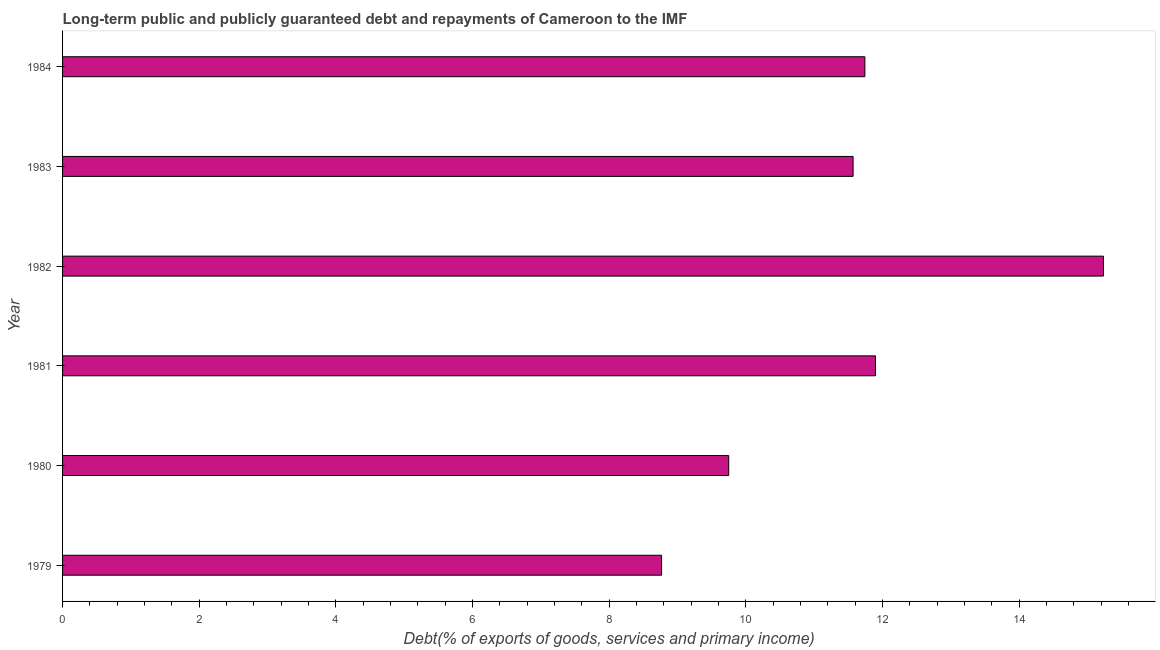Does the graph contain grids?
Your response must be concise. No. What is the title of the graph?
Make the answer very short. Long-term public and publicly guaranteed debt and repayments of Cameroon to the IMF. What is the label or title of the X-axis?
Make the answer very short. Debt(% of exports of goods, services and primary income). What is the label or title of the Y-axis?
Your answer should be very brief. Year. What is the debt service in 1981?
Ensure brevity in your answer.  11.9. Across all years, what is the maximum debt service?
Your answer should be very brief. 15.23. Across all years, what is the minimum debt service?
Provide a short and direct response. 8.77. In which year was the debt service minimum?
Offer a terse response. 1979. What is the sum of the debt service?
Make the answer very short. 68.95. What is the difference between the debt service in 1983 and 1984?
Offer a terse response. -0.17. What is the average debt service per year?
Offer a terse response. 11.49. What is the median debt service?
Keep it short and to the point. 11.65. In how many years, is the debt service greater than 4 %?
Provide a short and direct response. 6. What is the ratio of the debt service in 1980 to that in 1983?
Provide a succinct answer. 0.84. Is the difference between the debt service in 1979 and 1983 greater than the difference between any two years?
Make the answer very short. No. What is the difference between the highest and the second highest debt service?
Your response must be concise. 3.34. Is the sum of the debt service in 1980 and 1984 greater than the maximum debt service across all years?
Make the answer very short. Yes. What is the difference between the highest and the lowest debt service?
Offer a very short reply. 6.47. Are all the bars in the graph horizontal?
Your response must be concise. Yes. How many years are there in the graph?
Offer a very short reply. 6. Are the values on the major ticks of X-axis written in scientific E-notation?
Provide a succinct answer. No. What is the Debt(% of exports of goods, services and primary income) in 1979?
Offer a terse response. 8.77. What is the Debt(% of exports of goods, services and primary income) in 1980?
Your response must be concise. 9.75. What is the Debt(% of exports of goods, services and primary income) in 1981?
Provide a short and direct response. 11.9. What is the Debt(% of exports of goods, services and primary income) of 1982?
Keep it short and to the point. 15.23. What is the Debt(% of exports of goods, services and primary income) in 1983?
Make the answer very short. 11.57. What is the Debt(% of exports of goods, services and primary income) in 1984?
Offer a terse response. 11.74. What is the difference between the Debt(% of exports of goods, services and primary income) in 1979 and 1980?
Your answer should be very brief. -0.98. What is the difference between the Debt(% of exports of goods, services and primary income) in 1979 and 1981?
Offer a very short reply. -3.13. What is the difference between the Debt(% of exports of goods, services and primary income) in 1979 and 1982?
Keep it short and to the point. -6.47. What is the difference between the Debt(% of exports of goods, services and primary income) in 1979 and 1983?
Ensure brevity in your answer.  -2.8. What is the difference between the Debt(% of exports of goods, services and primary income) in 1979 and 1984?
Make the answer very short. -2.97. What is the difference between the Debt(% of exports of goods, services and primary income) in 1980 and 1981?
Your answer should be compact. -2.15. What is the difference between the Debt(% of exports of goods, services and primary income) in 1980 and 1982?
Offer a very short reply. -5.48. What is the difference between the Debt(% of exports of goods, services and primary income) in 1980 and 1983?
Give a very brief answer. -1.82. What is the difference between the Debt(% of exports of goods, services and primary income) in 1980 and 1984?
Provide a short and direct response. -1.99. What is the difference between the Debt(% of exports of goods, services and primary income) in 1981 and 1982?
Provide a succinct answer. -3.34. What is the difference between the Debt(% of exports of goods, services and primary income) in 1981 and 1983?
Offer a very short reply. 0.33. What is the difference between the Debt(% of exports of goods, services and primary income) in 1981 and 1984?
Your answer should be compact. 0.16. What is the difference between the Debt(% of exports of goods, services and primary income) in 1982 and 1983?
Offer a very short reply. 3.66. What is the difference between the Debt(% of exports of goods, services and primary income) in 1982 and 1984?
Ensure brevity in your answer.  3.49. What is the difference between the Debt(% of exports of goods, services and primary income) in 1983 and 1984?
Provide a short and direct response. -0.17. What is the ratio of the Debt(% of exports of goods, services and primary income) in 1979 to that in 1980?
Give a very brief answer. 0.9. What is the ratio of the Debt(% of exports of goods, services and primary income) in 1979 to that in 1981?
Give a very brief answer. 0.74. What is the ratio of the Debt(% of exports of goods, services and primary income) in 1979 to that in 1982?
Offer a very short reply. 0.57. What is the ratio of the Debt(% of exports of goods, services and primary income) in 1979 to that in 1983?
Your answer should be compact. 0.76. What is the ratio of the Debt(% of exports of goods, services and primary income) in 1979 to that in 1984?
Make the answer very short. 0.75. What is the ratio of the Debt(% of exports of goods, services and primary income) in 1980 to that in 1981?
Keep it short and to the point. 0.82. What is the ratio of the Debt(% of exports of goods, services and primary income) in 1980 to that in 1982?
Make the answer very short. 0.64. What is the ratio of the Debt(% of exports of goods, services and primary income) in 1980 to that in 1983?
Provide a succinct answer. 0.84. What is the ratio of the Debt(% of exports of goods, services and primary income) in 1980 to that in 1984?
Offer a terse response. 0.83. What is the ratio of the Debt(% of exports of goods, services and primary income) in 1981 to that in 1982?
Offer a terse response. 0.78. What is the ratio of the Debt(% of exports of goods, services and primary income) in 1981 to that in 1983?
Provide a short and direct response. 1.03. What is the ratio of the Debt(% of exports of goods, services and primary income) in 1982 to that in 1983?
Your answer should be very brief. 1.32. What is the ratio of the Debt(% of exports of goods, services and primary income) in 1982 to that in 1984?
Provide a short and direct response. 1.3. What is the ratio of the Debt(% of exports of goods, services and primary income) in 1983 to that in 1984?
Provide a succinct answer. 0.98. 